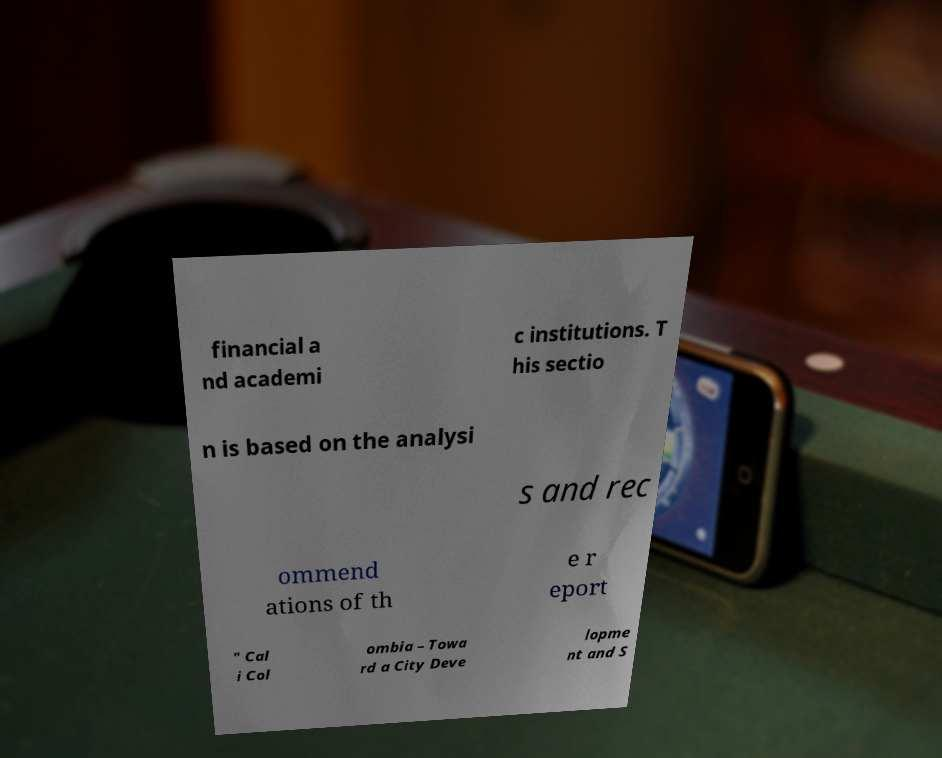For documentation purposes, I need the text within this image transcribed. Could you provide that? financial a nd academi c institutions. T his sectio n is based on the analysi s and rec ommend ations of th e r eport " Cal i Col ombia – Towa rd a City Deve lopme nt and S 